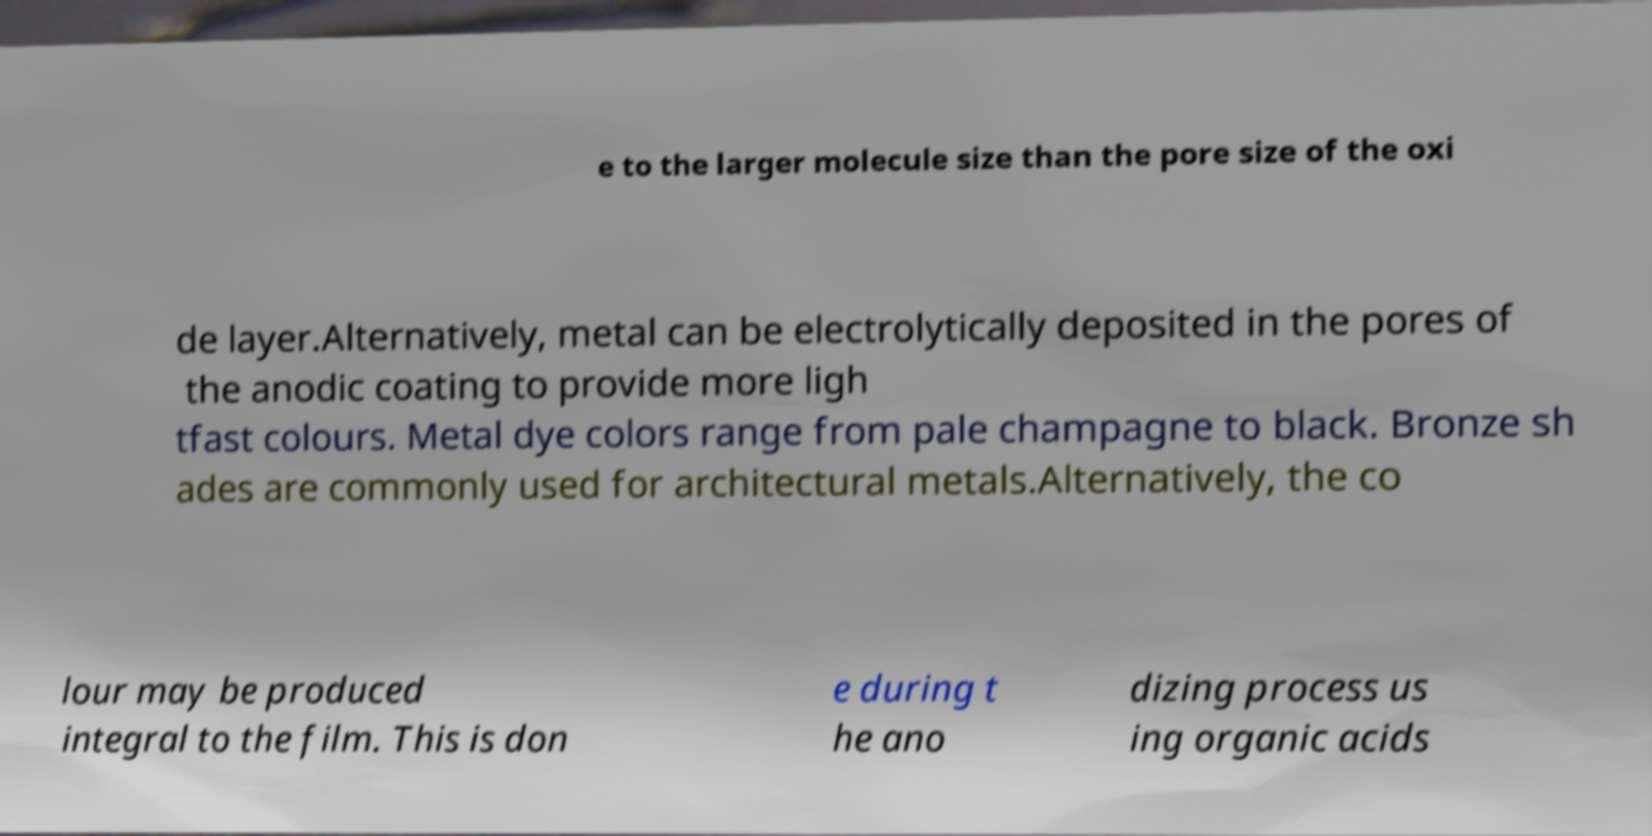For documentation purposes, I need the text within this image transcribed. Could you provide that? e to the larger molecule size than the pore size of the oxi de layer.Alternatively, metal can be electrolytically deposited in the pores of the anodic coating to provide more ligh tfast colours. Metal dye colors range from pale champagne to black. Bronze sh ades are commonly used for architectural metals.Alternatively, the co lour may be produced integral to the film. This is don e during t he ano dizing process us ing organic acids 